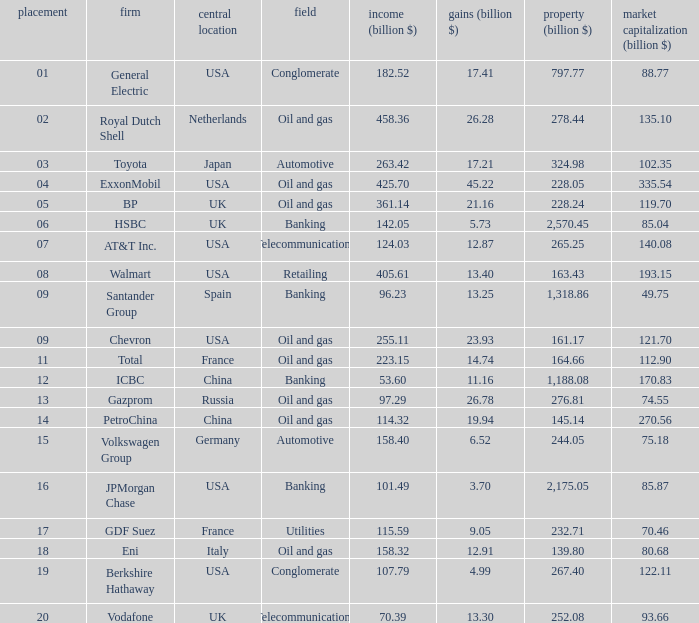Name the lowest Market Value (billion $) which has Assets (billion $) larger than 276.81, and a Company of toyota, and Profits (billion $) larger than 17.21? None. Would you be able to parse every entry in this table? {'header': ['placement', 'firm', 'central location', 'field', 'income (billion $)', 'gains (billion $)', 'property (billion $)', 'market capitalization (billion $)'], 'rows': [['01', 'General Electric', 'USA', 'Conglomerate', '182.52', '17.41', '797.77', '88.77'], ['02', 'Royal Dutch Shell', 'Netherlands', 'Oil and gas', '458.36', '26.28', '278.44', '135.10'], ['03', 'Toyota', 'Japan', 'Automotive', '263.42', '17.21', '324.98', '102.35'], ['04', 'ExxonMobil', 'USA', 'Oil and gas', '425.70', '45.22', '228.05', '335.54'], ['05', 'BP', 'UK', 'Oil and gas', '361.14', '21.16', '228.24', '119.70'], ['06', 'HSBC', 'UK', 'Banking', '142.05', '5.73', '2,570.45', '85.04'], ['07', 'AT&T Inc.', 'USA', 'Telecommunications', '124.03', '12.87', '265.25', '140.08'], ['08', 'Walmart', 'USA', 'Retailing', '405.61', '13.40', '163.43', '193.15'], ['09', 'Santander Group', 'Spain', 'Banking', '96.23', '13.25', '1,318.86', '49.75'], ['09', 'Chevron', 'USA', 'Oil and gas', '255.11', '23.93', '161.17', '121.70'], ['11', 'Total', 'France', 'Oil and gas', '223.15', '14.74', '164.66', '112.90'], ['12', 'ICBC', 'China', 'Banking', '53.60', '11.16', '1,188.08', '170.83'], ['13', 'Gazprom', 'Russia', 'Oil and gas', '97.29', '26.78', '276.81', '74.55'], ['14', 'PetroChina', 'China', 'Oil and gas', '114.32', '19.94', '145.14', '270.56'], ['15', 'Volkswagen Group', 'Germany', 'Automotive', '158.40', '6.52', '244.05', '75.18'], ['16', 'JPMorgan Chase', 'USA', 'Banking', '101.49', '3.70', '2,175.05', '85.87'], ['17', 'GDF Suez', 'France', 'Utilities', '115.59', '9.05', '232.71', '70.46'], ['18', 'Eni', 'Italy', 'Oil and gas', '158.32', '12.91', '139.80', '80.68'], ['19', 'Berkshire Hathaway', 'USA', 'Conglomerate', '107.79', '4.99', '267.40', '122.11'], ['20', 'Vodafone', 'UK', 'Telecommunications', '70.39', '13.30', '252.08', '93.66']]} 